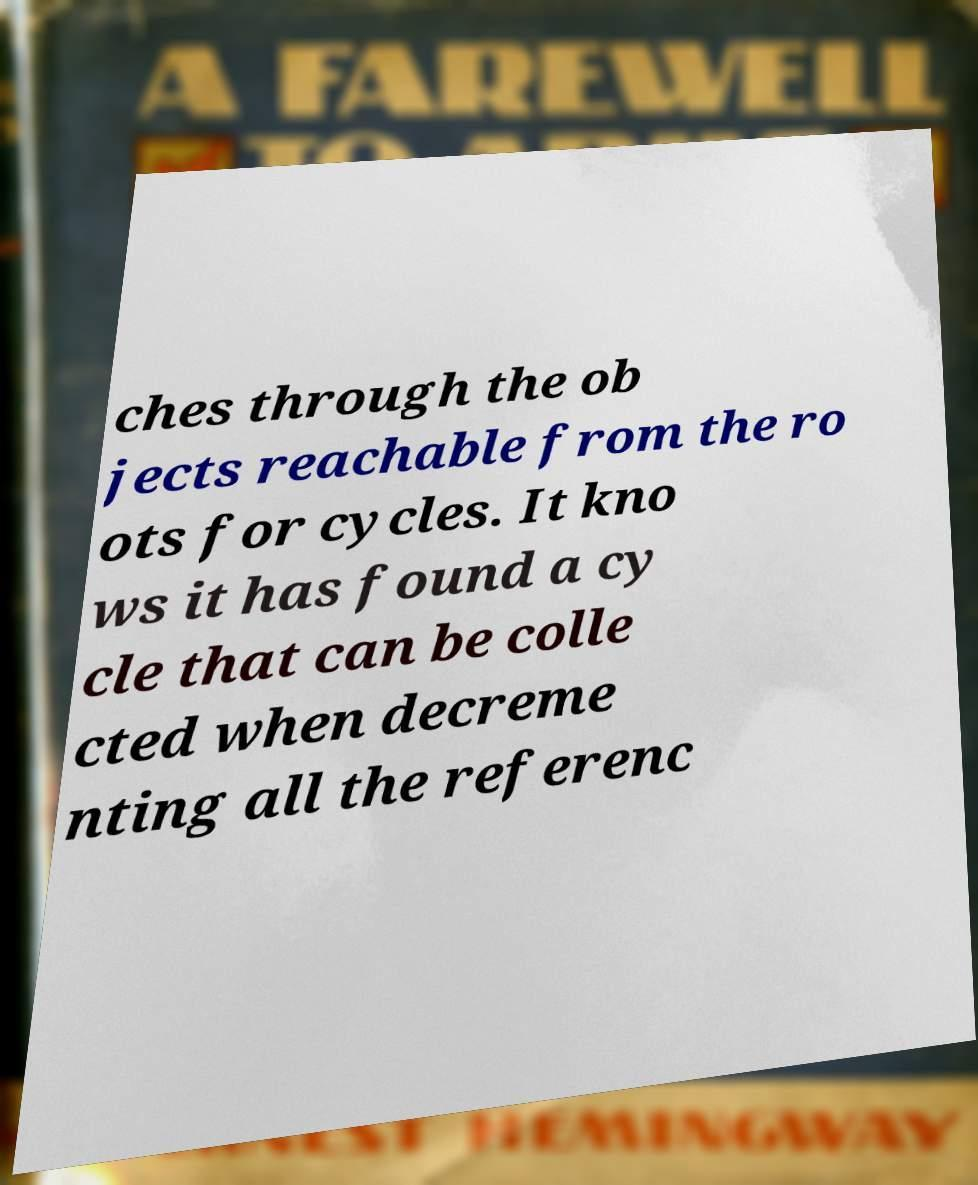Can you accurately transcribe the text from the provided image for me? ches through the ob jects reachable from the ro ots for cycles. It kno ws it has found a cy cle that can be colle cted when decreme nting all the referenc 